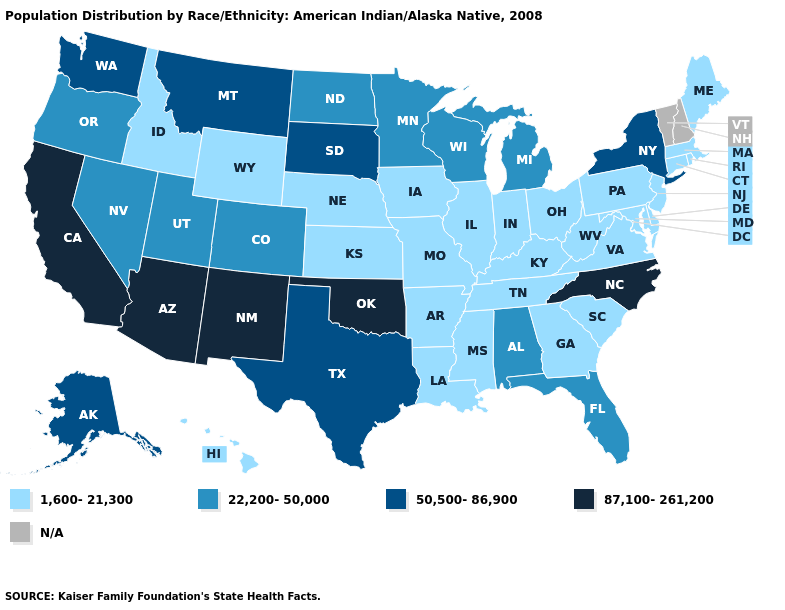What is the lowest value in the USA?
Give a very brief answer. 1,600-21,300. What is the lowest value in the West?
Be succinct. 1,600-21,300. Is the legend a continuous bar?
Short answer required. No. Name the states that have a value in the range N/A?
Be succinct. New Hampshire, Vermont. Name the states that have a value in the range 87,100-261,200?
Answer briefly. Arizona, California, New Mexico, North Carolina, Oklahoma. Does the map have missing data?
Give a very brief answer. Yes. What is the lowest value in the Northeast?
Write a very short answer. 1,600-21,300. What is the lowest value in the West?
Write a very short answer. 1,600-21,300. What is the highest value in states that border Missouri?
Be succinct. 87,100-261,200. Among the states that border Ohio , which have the lowest value?
Quick response, please. Indiana, Kentucky, Pennsylvania, West Virginia. Name the states that have a value in the range 1,600-21,300?
Keep it brief. Arkansas, Connecticut, Delaware, Georgia, Hawaii, Idaho, Illinois, Indiana, Iowa, Kansas, Kentucky, Louisiana, Maine, Maryland, Massachusetts, Mississippi, Missouri, Nebraska, New Jersey, Ohio, Pennsylvania, Rhode Island, South Carolina, Tennessee, Virginia, West Virginia, Wyoming. What is the value of South Dakota?
Quick response, please. 50,500-86,900. What is the value of Texas?
Write a very short answer. 50,500-86,900. Name the states that have a value in the range 87,100-261,200?
Answer briefly. Arizona, California, New Mexico, North Carolina, Oklahoma. 